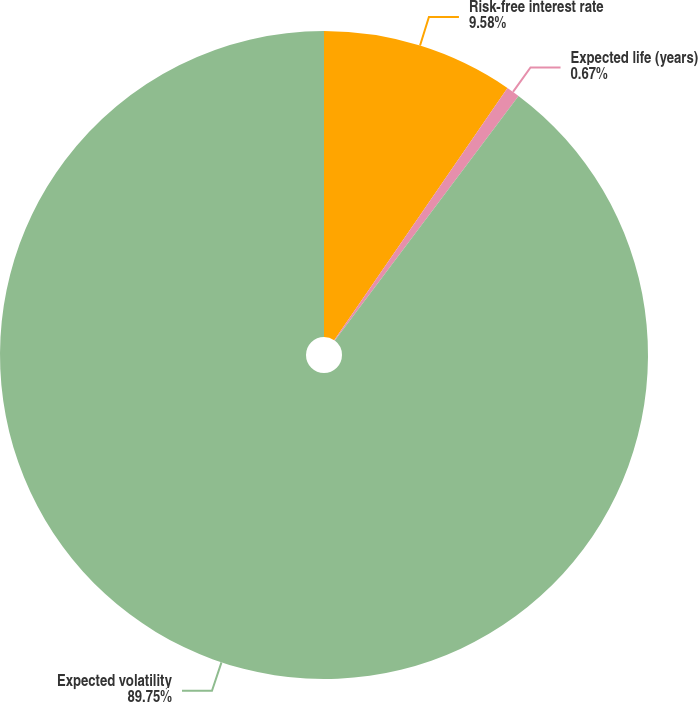Convert chart. <chart><loc_0><loc_0><loc_500><loc_500><pie_chart><fcel>Risk-free interest rate<fcel>Expected life (years)<fcel>Expected volatility<nl><fcel>9.58%<fcel>0.67%<fcel>89.76%<nl></chart> 